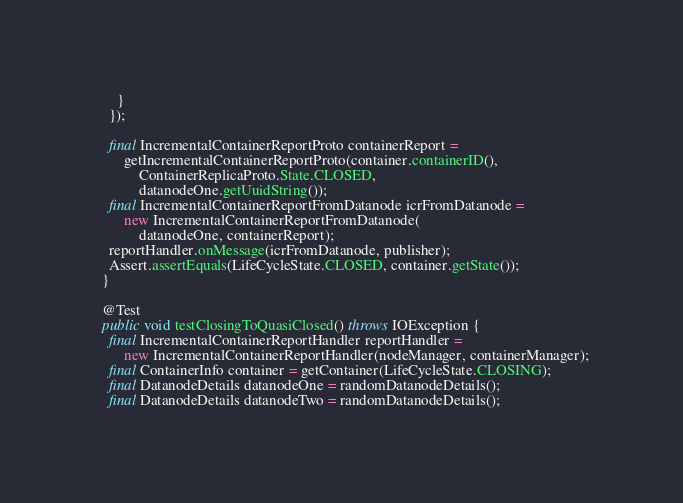<code> <loc_0><loc_0><loc_500><loc_500><_Java_>      }
    });

    final IncrementalContainerReportProto containerReport =
        getIncrementalContainerReportProto(container.containerID(),
            ContainerReplicaProto.State.CLOSED,
            datanodeOne.getUuidString());
    final IncrementalContainerReportFromDatanode icrFromDatanode =
        new IncrementalContainerReportFromDatanode(
            datanodeOne, containerReport);
    reportHandler.onMessage(icrFromDatanode, publisher);
    Assert.assertEquals(LifeCycleState.CLOSED, container.getState());
  }

  @Test
  public void testClosingToQuasiClosed() throws IOException {
    final IncrementalContainerReportHandler reportHandler =
        new IncrementalContainerReportHandler(nodeManager, containerManager);
    final ContainerInfo container = getContainer(LifeCycleState.CLOSING);
    final DatanodeDetails datanodeOne = randomDatanodeDetails();
    final DatanodeDetails datanodeTwo = randomDatanodeDetails();</code> 